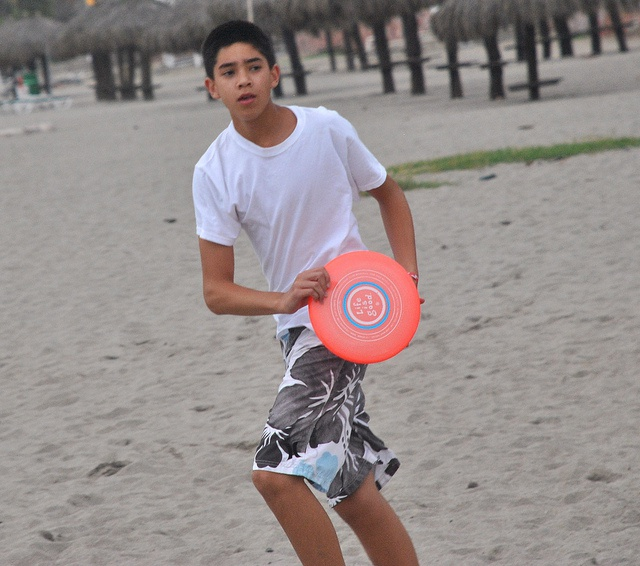Describe the objects in this image and their specific colors. I can see people in gray, darkgray, and brown tones and frisbee in gray and salmon tones in this image. 